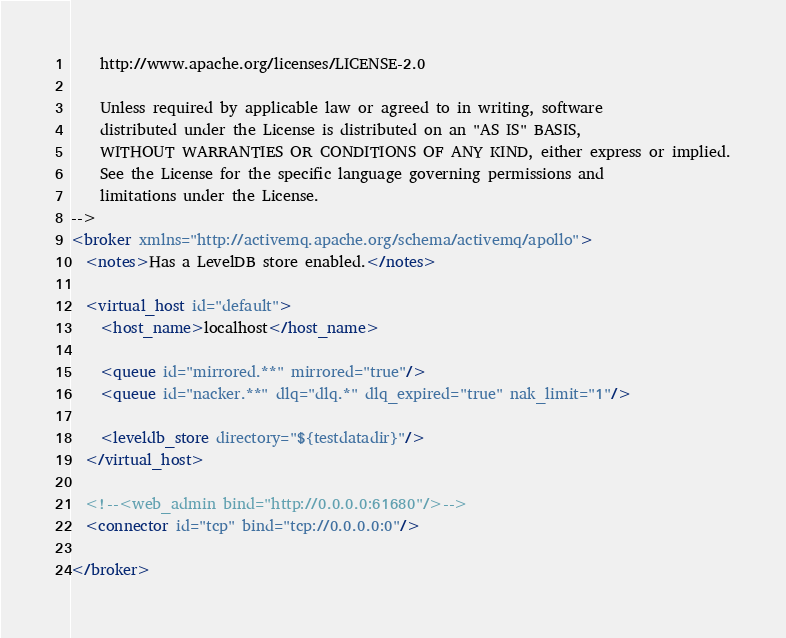<code> <loc_0><loc_0><loc_500><loc_500><_XML_>
    http://www.apache.org/licenses/LICENSE-2.0

    Unless required by applicable law or agreed to in writing, software
    distributed under the License is distributed on an "AS IS" BASIS,
    WITHOUT WARRANTIES OR CONDITIONS OF ANY KIND, either express or implied.
    See the License for the specific language governing permissions and
    limitations under the License.
-->
<broker xmlns="http://activemq.apache.org/schema/activemq/apollo">
  <notes>Has a LevelDB store enabled.</notes>

  <virtual_host id="default">
    <host_name>localhost</host_name>

    <queue id="mirrored.**" mirrored="true"/>
    <queue id="nacker.**" dlq="dlq.*" dlq_expired="true" nak_limit="1"/>

    <leveldb_store directory="${testdatadir}"/>
  </virtual_host>

  <!--<web_admin bind="http://0.0.0.0:61680"/>-->
  <connector id="tcp" bind="tcp://0.0.0.0:0"/>

</broker></code> 